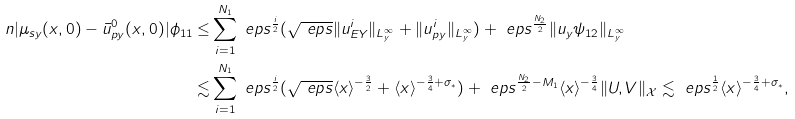<formula> <loc_0><loc_0><loc_500><loc_500>\ n | \mu _ { s y } ( x , 0 ) - \bar { u } ^ { 0 } _ { p y } ( x , 0 ) | \phi _ { 1 1 } \leq & \sum _ { i = 1 } ^ { N _ { 1 } } \ e p s ^ { \frac { i } { 2 } } ( \sqrt { \ e p s } \| u ^ { i } _ { E Y } \| _ { L ^ { \infty } _ { y } } + \| u ^ { i } _ { p y } \| _ { L ^ { \infty } _ { y } } ) + \ e p s ^ { \frac { N _ { 2 } } { 2 } } \| u _ { y } \psi _ { 1 2 } \| _ { L ^ { \infty } _ { y } } \\ \lesssim & \sum _ { i = 1 } ^ { N _ { 1 } } \ e p s ^ { \frac { i } { 2 } } ( \sqrt { \ e p s } \langle x \rangle ^ { - \frac { 3 } { 2 } } + \langle x \rangle ^ { - \frac { 3 } { 4 } + \sigma _ { \ast } } ) + \ e p s ^ { \frac { N _ { 2 } } { 2 } - M _ { 1 } } \langle x \rangle ^ { - \frac { 3 } { 4 } } \| U , V \| _ { \mathcal { X } } \lesssim \ e p s ^ { \frac { 1 } { 2 } } \langle x \rangle ^ { - \frac { 3 } { 4 } + \sigma _ { \ast } } ,</formula> 